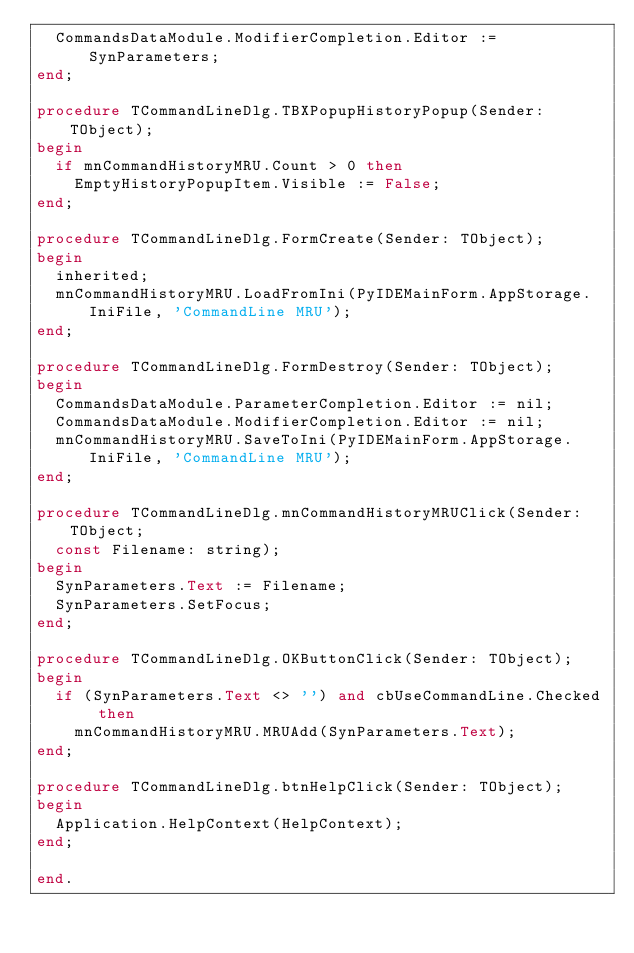<code> <loc_0><loc_0><loc_500><loc_500><_Pascal_>  CommandsDataModule.ModifierCompletion.Editor := SynParameters;
end;

procedure TCommandLineDlg.TBXPopupHistoryPopup(Sender: TObject);
begin
  if mnCommandHistoryMRU.Count > 0 then
    EmptyHistoryPopupItem.Visible := False;
end;

procedure TCommandLineDlg.FormCreate(Sender: TObject);
begin
  inherited;
  mnCommandHistoryMRU.LoadFromIni(PyIDEMainForm.AppStorage.IniFile, 'CommandLine MRU');
end;

procedure TCommandLineDlg.FormDestroy(Sender: TObject);
begin
  CommandsDataModule.ParameterCompletion.Editor := nil;
  CommandsDataModule.ModifierCompletion.Editor := nil;
  mnCommandHistoryMRU.SaveToIni(PyIDEMainForm.AppStorage.IniFile, 'CommandLine MRU');
end;

procedure TCommandLineDlg.mnCommandHistoryMRUClick(Sender: TObject;
  const Filename: string);
begin
  SynParameters.Text := Filename;
  SynParameters.SetFocus;
end;

procedure TCommandLineDlg.OKButtonClick(Sender: TObject);
begin
  if (SynParameters.Text <> '') and cbUseCommandLine.Checked then
    mnCommandHistoryMRU.MRUAdd(SynParameters.Text);
end;

procedure TCommandLineDlg.btnHelpClick(Sender: TObject);
begin
  Application.HelpContext(HelpContext);
end;

end.
</code> 